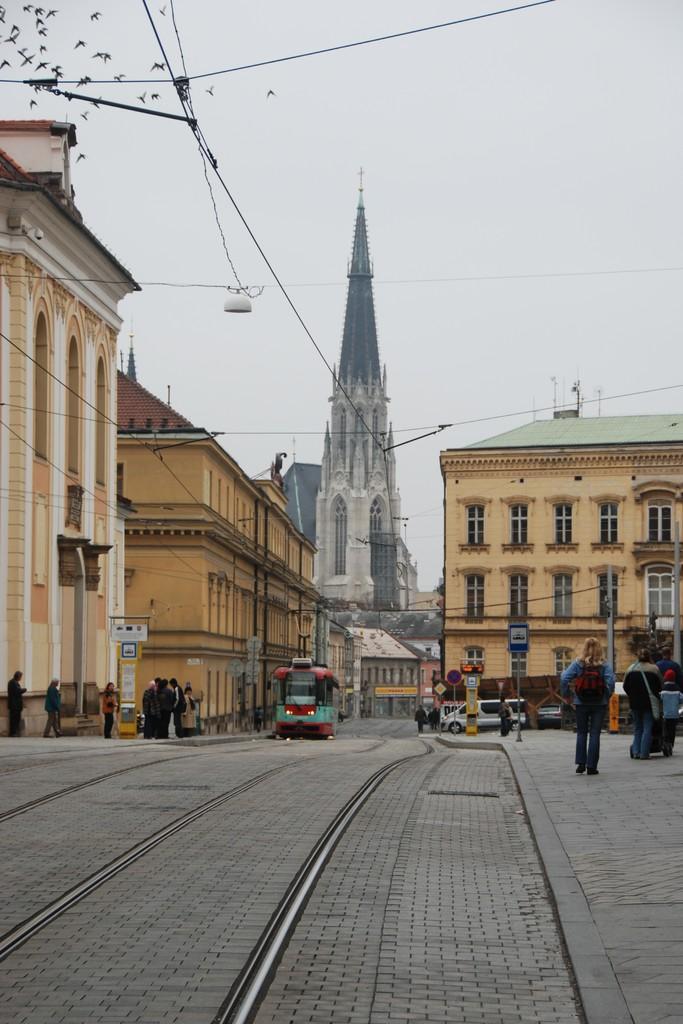Describe this image in one or two sentences. There is a road in the foreground area of the image, there are people, vehicles, poles, buildings, birds, wires and the sky in the background. 